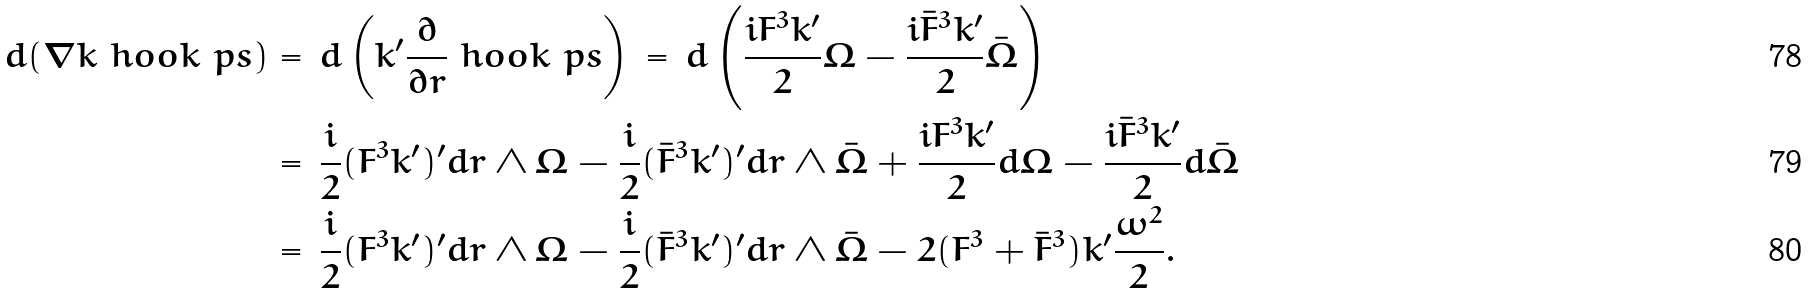<formula> <loc_0><loc_0><loc_500><loc_500>d ( { \nabla k } \ h o o k \ p s ) & = \, d \left ( k ^ { \prime } \frac { \partial } { \partial r } \ h o o k \ p s \right ) \, = \, d \left ( \frac { i F ^ { 3 } k ^ { \prime } } { 2 } \Omega - \frac { i \bar { F } ^ { 3 } k ^ { \prime } } { 2 } \bar { \Omega } \right ) \\ & = \, \frac { i } { 2 } ( F ^ { 3 } k ^ { \prime } ) ^ { \prime } d r \wedge \Omega - \frac { i } { 2 } ( \bar { F } ^ { 3 } k ^ { \prime } ) ^ { \prime } d r \wedge \bar { \Omega } + \frac { i F ^ { 3 } k ^ { \prime } } { 2 } d \Omega - \frac { i \bar { F } ^ { 3 } k ^ { \prime } } { 2 } d \bar { \Omega } \\ & = \, \frac { i } { 2 } ( F ^ { 3 } k ^ { \prime } ) ^ { \prime } d r \wedge \Omega - \frac { i } { 2 } ( \bar { F } ^ { 3 } k ^ { \prime } ) ^ { \prime } d r \wedge \bar { \Omega } - 2 ( F ^ { 3 } + \bar { F } ^ { 3 } ) k ^ { \prime } \frac { \omega ^ { 2 } } { 2 } .</formula> 